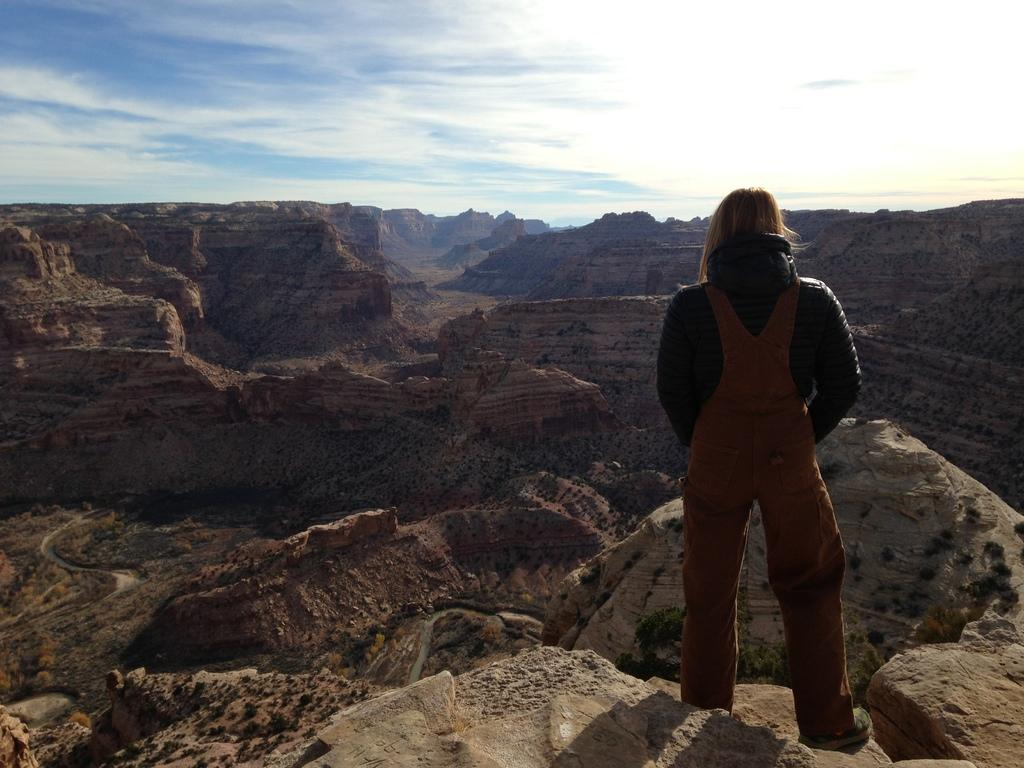Who or what is located at the right side of the image? There is a person standing at the right side of the image. What type of natural landscape can be seen in the image? There are mountains visible in the image. What is visible at the top of the image? The sky is visible at the top of the image. What type of grass is being used as a writing surface by the writer in the image? There is no writer or grass present in the image. 